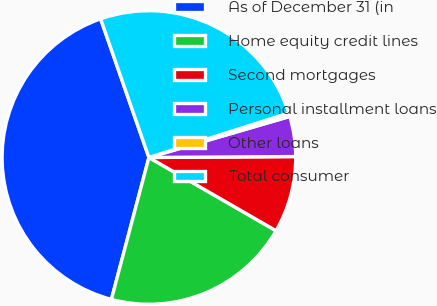<chart> <loc_0><loc_0><loc_500><loc_500><pie_chart><fcel>As of December 31 (in<fcel>Home equity credit lines<fcel>Second mortgages<fcel>Personal installment loans<fcel>Other loans<fcel>Total consumer<nl><fcel>40.55%<fcel>20.79%<fcel>8.42%<fcel>4.41%<fcel>0.39%<fcel>25.43%<nl></chart> 